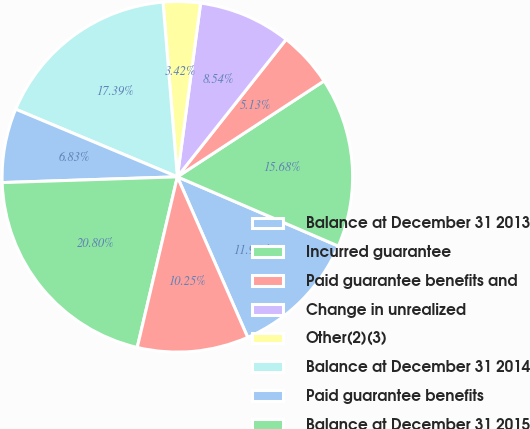<chart> <loc_0><loc_0><loc_500><loc_500><pie_chart><fcel>Balance at December 31 2013<fcel>Incurred guarantee<fcel>Paid guarantee benefits and<fcel>Change in unrealized<fcel>Other(2)(3)<fcel>Balance at December 31 2014<fcel>Paid guarantee benefits<fcel>Balance at December 31 2015<fcel>Incurred guarantee benefits(1)<nl><fcel>11.96%<fcel>15.68%<fcel>5.13%<fcel>8.54%<fcel>3.42%<fcel>17.39%<fcel>6.83%<fcel>20.8%<fcel>10.25%<nl></chart> 